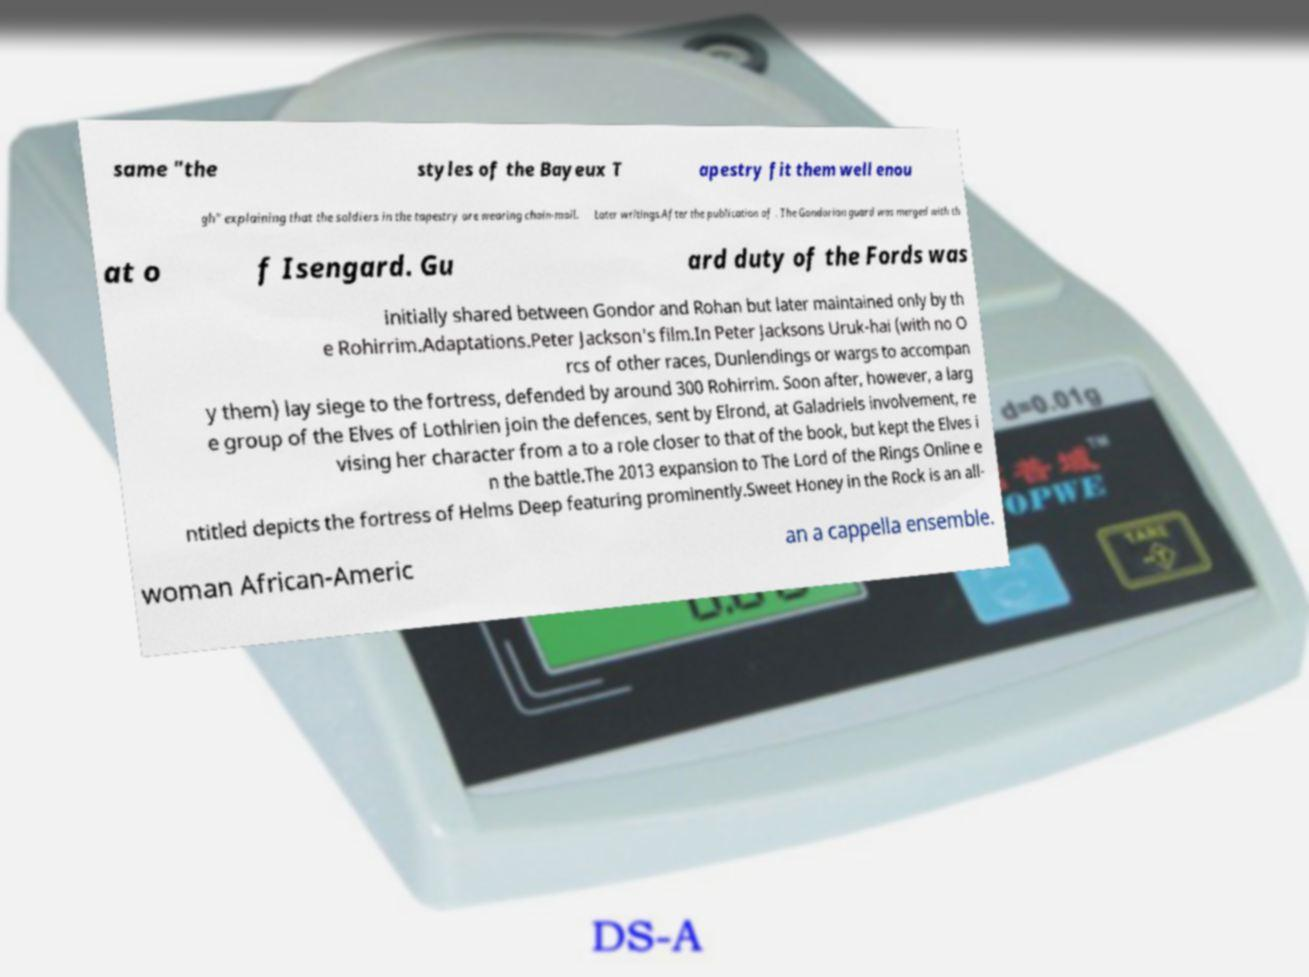Please identify and transcribe the text found in this image. same "the styles of the Bayeux T apestry fit them well enou gh" explaining that the soldiers in the tapestry are wearing chain-mail. Later writings.After the publication of . The Gondorian guard was merged with th at o f Isengard. Gu ard duty of the Fords was initially shared between Gondor and Rohan but later maintained only by th e Rohirrim.Adaptations.Peter Jackson's film.In Peter Jacksons Uruk-hai (with no O rcs of other races, Dunlendings or wargs to accompan y them) lay siege to the fortress, defended by around 300 Rohirrim. Soon after, however, a larg e group of the Elves of Lothlrien join the defences, sent by Elrond, at Galadriels involvement, re vising her character from a to a role closer to that of the book, but kept the Elves i n the battle.The 2013 expansion to The Lord of the Rings Online e ntitled depicts the fortress of Helms Deep featuring prominently.Sweet Honey in the Rock is an all- woman African-Americ an a cappella ensemble. 